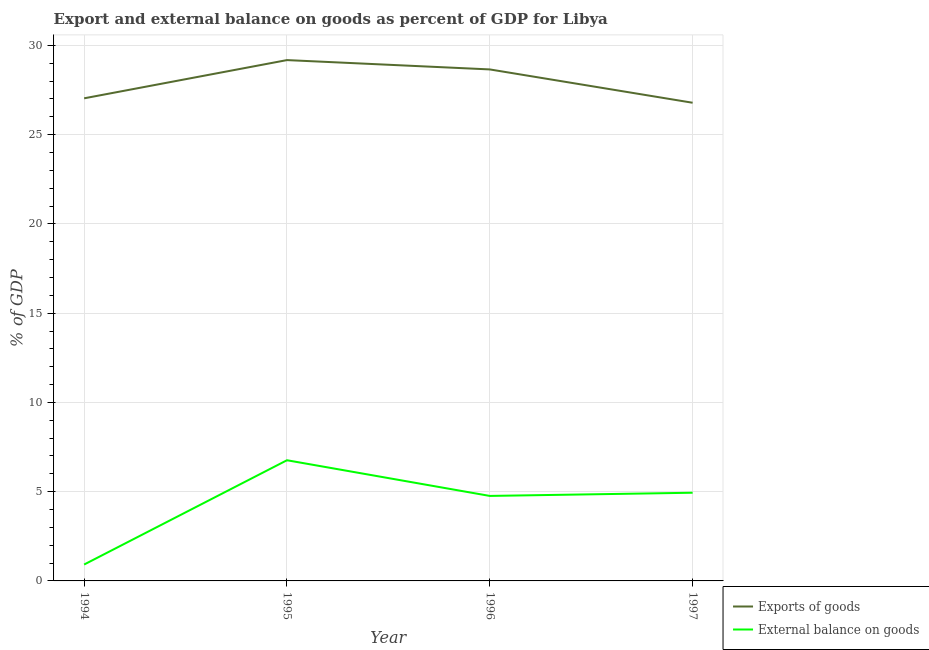Is the number of lines equal to the number of legend labels?
Provide a succinct answer. Yes. What is the export of goods as percentage of gdp in 1997?
Your response must be concise. 26.79. Across all years, what is the maximum export of goods as percentage of gdp?
Give a very brief answer. 29.18. Across all years, what is the minimum external balance on goods as percentage of gdp?
Provide a succinct answer. 0.92. What is the total external balance on goods as percentage of gdp in the graph?
Ensure brevity in your answer.  17.38. What is the difference between the external balance on goods as percentage of gdp in 1994 and that in 1997?
Your answer should be very brief. -4.02. What is the difference between the external balance on goods as percentage of gdp in 1996 and the export of goods as percentage of gdp in 1997?
Your response must be concise. -22.02. What is the average export of goods as percentage of gdp per year?
Ensure brevity in your answer.  27.91. In the year 1997, what is the difference between the export of goods as percentage of gdp and external balance on goods as percentage of gdp?
Give a very brief answer. 21.85. In how many years, is the external balance on goods as percentage of gdp greater than 5 %?
Ensure brevity in your answer.  1. What is the ratio of the external balance on goods as percentage of gdp in 1995 to that in 1996?
Your answer should be very brief. 1.42. Is the export of goods as percentage of gdp in 1994 less than that in 1995?
Provide a short and direct response. Yes. Is the difference between the export of goods as percentage of gdp in 1996 and 1997 greater than the difference between the external balance on goods as percentage of gdp in 1996 and 1997?
Your answer should be compact. Yes. What is the difference between the highest and the second highest external balance on goods as percentage of gdp?
Provide a short and direct response. 1.82. What is the difference between the highest and the lowest external balance on goods as percentage of gdp?
Offer a terse response. 5.84. In how many years, is the external balance on goods as percentage of gdp greater than the average external balance on goods as percentage of gdp taken over all years?
Your response must be concise. 3. Is the sum of the external balance on goods as percentage of gdp in 1994 and 1997 greater than the maximum export of goods as percentage of gdp across all years?
Your response must be concise. No. How many years are there in the graph?
Ensure brevity in your answer.  4. Are the values on the major ticks of Y-axis written in scientific E-notation?
Your response must be concise. No. Does the graph contain grids?
Ensure brevity in your answer.  Yes. What is the title of the graph?
Ensure brevity in your answer.  Export and external balance on goods as percent of GDP for Libya. Does "State government" appear as one of the legend labels in the graph?
Provide a succinct answer. No. What is the label or title of the Y-axis?
Your answer should be very brief. % of GDP. What is the % of GDP in Exports of goods in 1994?
Give a very brief answer. 27.04. What is the % of GDP in External balance on goods in 1994?
Offer a very short reply. 0.92. What is the % of GDP in Exports of goods in 1995?
Offer a terse response. 29.18. What is the % of GDP of External balance on goods in 1995?
Your answer should be very brief. 6.76. What is the % of GDP in Exports of goods in 1996?
Ensure brevity in your answer.  28.65. What is the % of GDP in External balance on goods in 1996?
Offer a very short reply. 4.76. What is the % of GDP of Exports of goods in 1997?
Your response must be concise. 26.79. What is the % of GDP of External balance on goods in 1997?
Offer a terse response. 4.94. Across all years, what is the maximum % of GDP of Exports of goods?
Your answer should be compact. 29.18. Across all years, what is the maximum % of GDP of External balance on goods?
Give a very brief answer. 6.76. Across all years, what is the minimum % of GDP of Exports of goods?
Offer a terse response. 26.79. Across all years, what is the minimum % of GDP of External balance on goods?
Give a very brief answer. 0.92. What is the total % of GDP of Exports of goods in the graph?
Offer a terse response. 111.65. What is the total % of GDP in External balance on goods in the graph?
Keep it short and to the point. 17.38. What is the difference between the % of GDP in Exports of goods in 1994 and that in 1995?
Your answer should be compact. -2.14. What is the difference between the % of GDP in External balance on goods in 1994 and that in 1995?
Provide a succinct answer. -5.84. What is the difference between the % of GDP of Exports of goods in 1994 and that in 1996?
Provide a short and direct response. -1.62. What is the difference between the % of GDP in External balance on goods in 1994 and that in 1996?
Ensure brevity in your answer.  -3.84. What is the difference between the % of GDP of Exports of goods in 1994 and that in 1997?
Your answer should be very brief. 0.25. What is the difference between the % of GDP of External balance on goods in 1994 and that in 1997?
Keep it short and to the point. -4.02. What is the difference between the % of GDP of Exports of goods in 1995 and that in 1996?
Your answer should be compact. 0.52. What is the difference between the % of GDP in External balance on goods in 1995 and that in 1996?
Keep it short and to the point. 2. What is the difference between the % of GDP of Exports of goods in 1995 and that in 1997?
Offer a very short reply. 2.39. What is the difference between the % of GDP in External balance on goods in 1995 and that in 1997?
Your answer should be very brief. 1.82. What is the difference between the % of GDP of Exports of goods in 1996 and that in 1997?
Ensure brevity in your answer.  1.87. What is the difference between the % of GDP of External balance on goods in 1996 and that in 1997?
Offer a terse response. -0.18. What is the difference between the % of GDP of Exports of goods in 1994 and the % of GDP of External balance on goods in 1995?
Give a very brief answer. 20.27. What is the difference between the % of GDP of Exports of goods in 1994 and the % of GDP of External balance on goods in 1996?
Ensure brevity in your answer.  22.27. What is the difference between the % of GDP of Exports of goods in 1994 and the % of GDP of External balance on goods in 1997?
Keep it short and to the point. 22.09. What is the difference between the % of GDP of Exports of goods in 1995 and the % of GDP of External balance on goods in 1996?
Make the answer very short. 24.41. What is the difference between the % of GDP in Exports of goods in 1995 and the % of GDP in External balance on goods in 1997?
Make the answer very short. 24.24. What is the difference between the % of GDP in Exports of goods in 1996 and the % of GDP in External balance on goods in 1997?
Your answer should be compact. 23.71. What is the average % of GDP of Exports of goods per year?
Your answer should be compact. 27.91. What is the average % of GDP in External balance on goods per year?
Offer a terse response. 4.35. In the year 1994, what is the difference between the % of GDP in Exports of goods and % of GDP in External balance on goods?
Give a very brief answer. 26.12. In the year 1995, what is the difference between the % of GDP in Exports of goods and % of GDP in External balance on goods?
Offer a terse response. 22.42. In the year 1996, what is the difference between the % of GDP in Exports of goods and % of GDP in External balance on goods?
Make the answer very short. 23.89. In the year 1997, what is the difference between the % of GDP in Exports of goods and % of GDP in External balance on goods?
Give a very brief answer. 21.85. What is the ratio of the % of GDP of Exports of goods in 1994 to that in 1995?
Give a very brief answer. 0.93. What is the ratio of the % of GDP of External balance on goods in 1994 to that in 1995?
Offer a very short reply. 0.14. What is the ratio of the % of GDP of Exports of goods in 1994 to that in 1996?
Your answer should be very brief. 0.94. What is the ratio of the % of GDP in External balance on goods in 1994 to that in 1996?
Ensure brevity in your answer.  0.19. What is the ratio of the % of GDP in Exports of goods in 1994 to that in 1997?
Offer a very short reply. 1.01. What is the ratio of the % of GDP in External balance on goods in 1994 to that in 1997?
Your response must be concise. 0.19. What is the ratio of the % of GDP of Exports of goods in 1995 to that in 1996?
Keep it short and to the point. 1.02. What is the ratio of the % of GDP of External balance on goods in 1995 to that in 1996?
Provide a succinct answer. 1.42. What is the ratio of the % of GDP in Exports of goods in 1995 to that in 1997?
Your answer should be compact. 1.09. What is the ratio of the % of GDP of External balance on goods in 1995 to that in 1997?
Your answer should be very brief. 1.37. What is the ratio of the % of GDP in Exports of goods in 1996 to that in 1997?
Make the answer very short. 1.07. What is the ratio of the % of GDP in External balance on goods in 1996 to that in 1997?
Provide a short and direct response. 0.96. What is the difference between the highest and the second highest % of GDP of Exports of goods?
Offer a terse response. 0.52. What is the difference between the highest and the second highest % of GDP of External balance on goods?
Provide a short and direct response. 1.82. What is the difference between the highest and the lowest % of GDP in Exports of goods?
Your answer should be compact. 2.39. What is the difference between the highest and the lowest % of GDP in External balance on goods?
Your response must be concise. 5.84. 